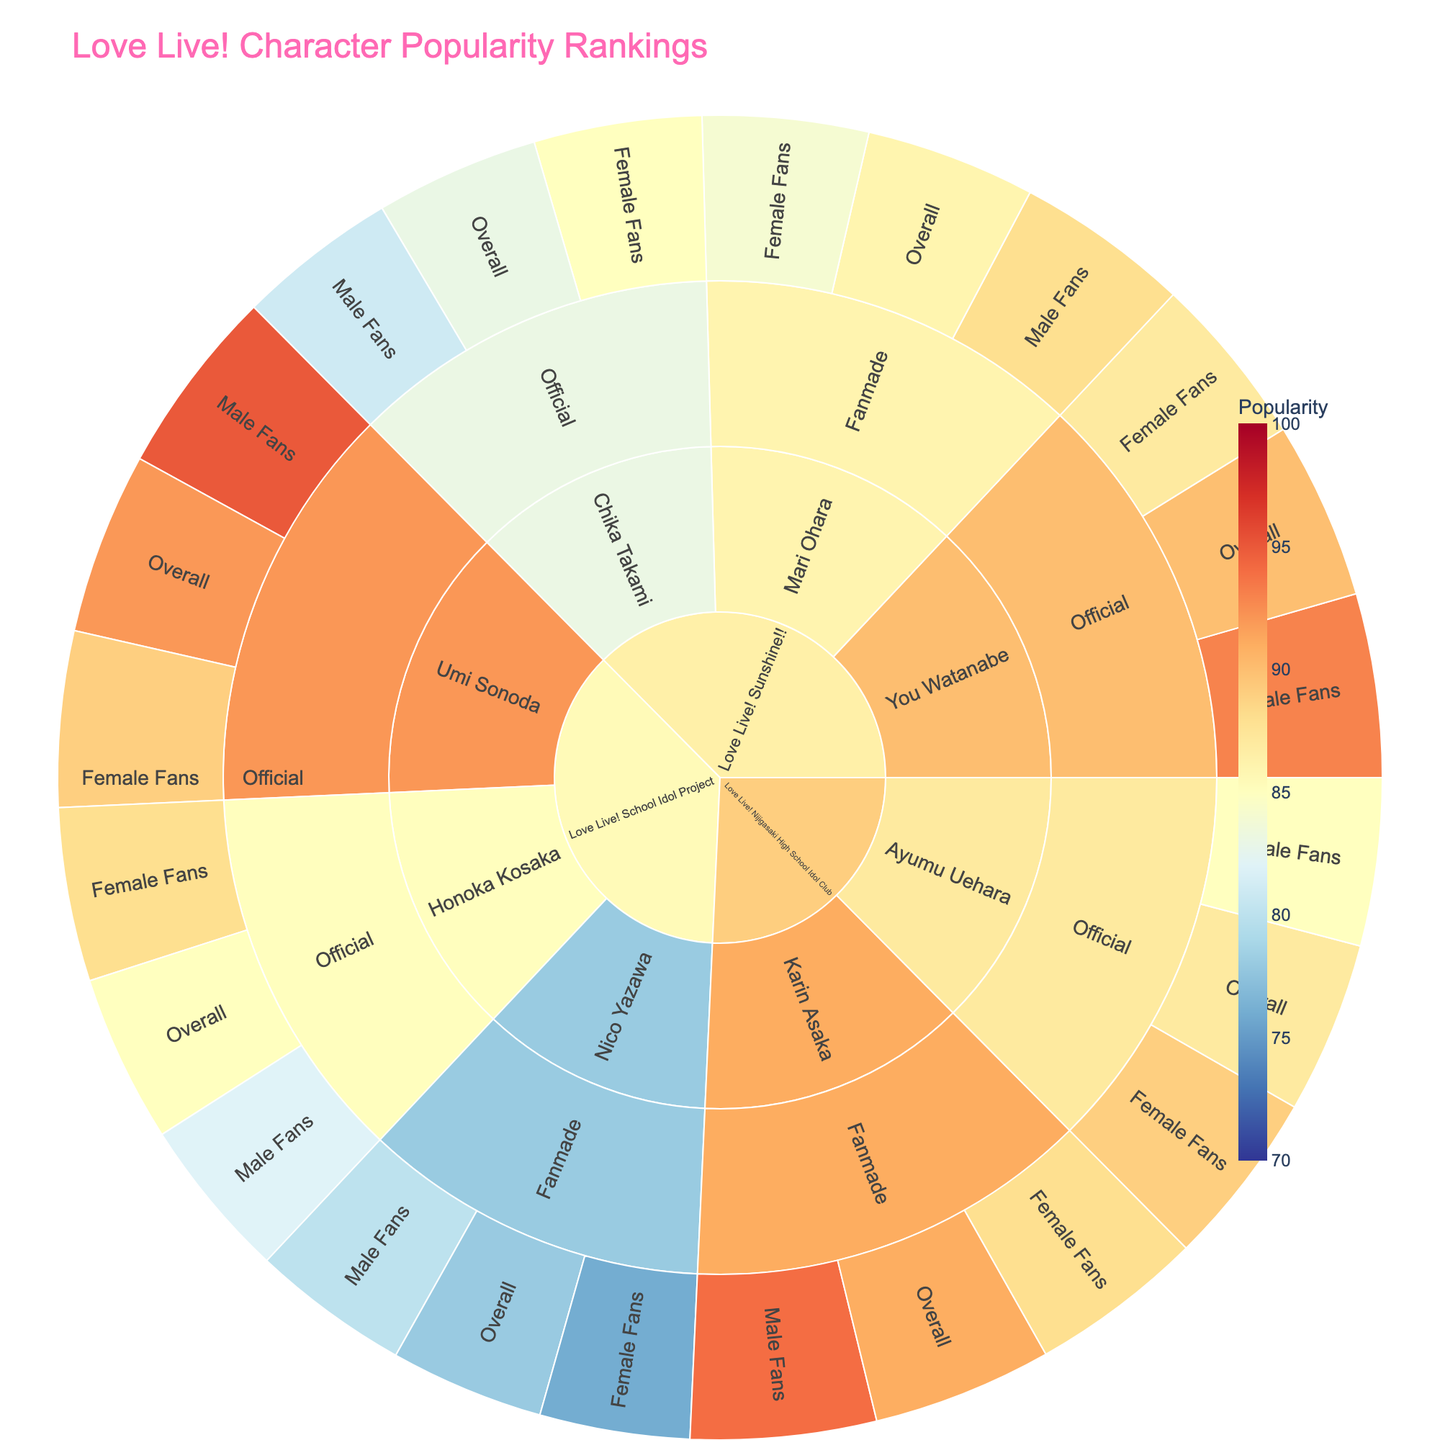what is the title of the sunburst plot? The title of a plot is usually prominently displayed at the top. For this plot, it is "Love Live! Character Popularity Rankings" based on the provided code.
Answer: Love Live! Character Popularity Rankings Which character has the highest popularity overall in "Love Live! School Idol Project"? By examining the sunburst plot and looking at the 'Overall' category in the "Love Live! School Idol Project" series, Umi Sonoda has the highest popularity with a value of 92.
Answer: Umi Sonoda What is the difference in popularity between male and female fans for Honoka Kosaka in the "Official" poll? In the "Love Live! School Idol Project" series, under Honoka Kosaka's "Official" poll category, the male popularity is 82 and the female popularity is 88. The difference is 88 - 82 = 6.
Answer: 6 Compare the overall popularity of Chika Takami in "Love Live! Sunshine!!" and Ayumu Uehara in "Love Live! Nijigasaki High School Idol Club". Chika Takami has an overall popularity of 83 in "Love Live! Sunshine!!" while Ayumu Uehara has an overall popularity of 87 in "Love Live! Nijigasaki High School Idol Club". Comparing these values, Ayumu Uehara has a higher overall popularity.
Answer: Ayumu Uehara Which fan demographic shows the highest popularity for You Watanabe in the "Official" poll? For You Watanabe in the "Official" poll under "Love Live! Sunshine!!", male fans show the highest popularity with a value of 93.
Answer: Male Fans Find the average popularity of female fans across all "Fanmade" polls. Female fan popularity values from "Fanmade" polls are 76 (Nico Yazawa, LL School Idol Project), 84 (Mari Ohara, LL Sunshine!!), and 88 (Karin Asaka, LL Nijigasaki HSIC). The average is (76 + 84 + 88) / 3 = 82.67.
Answer: 82.67 What is the highest popularity score in the "Fanmade" poll for the "Love Live! Nijigasaki High School Idol Club" series? In the "Fanmade" poll for "Love Live! Nijigasaki High School Idol Club", Karin Asaka's male fan popularity score is the highest at 94.
Answer: 94 Identify the character with the highest female popularity in "Love Live! Sunshine!!". You need to check the female popularity values under the "Love Live! Sunshine!!" series. You Watanabe has the highest female popularity with a value of 87.
Answer: You Watanabe 